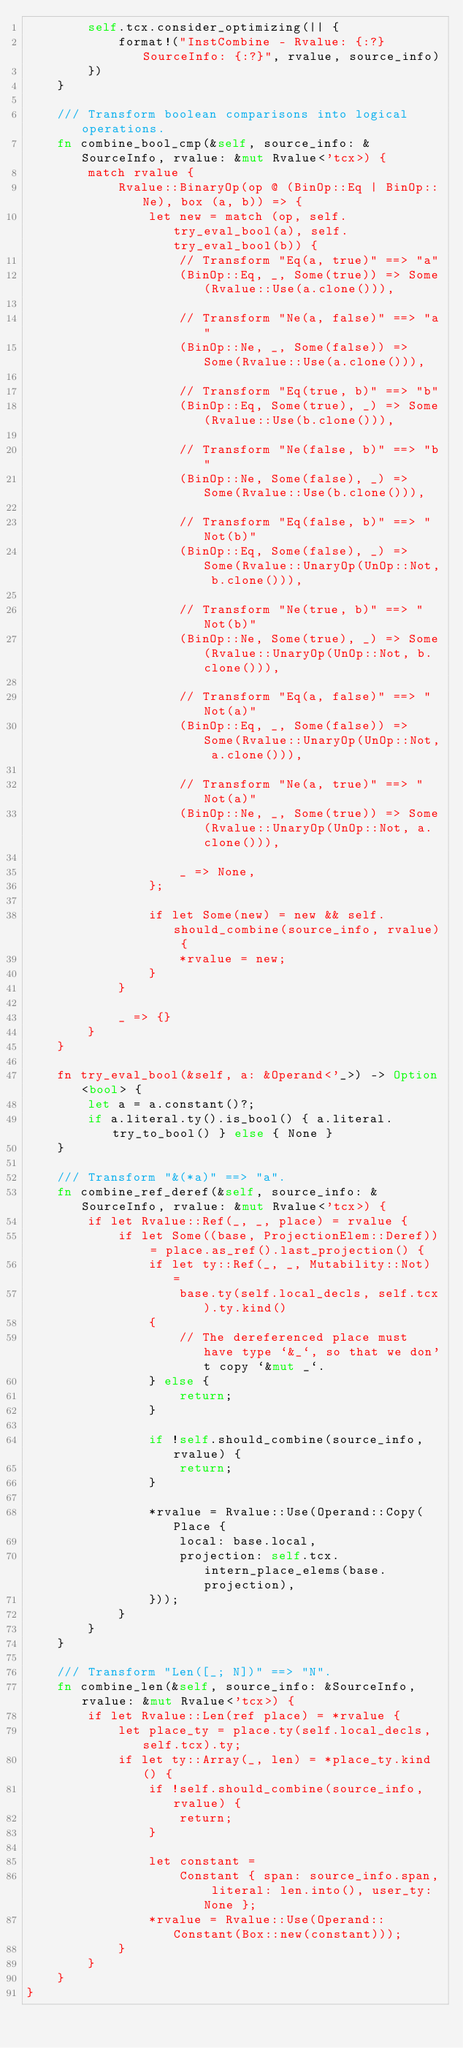Convert code to text. <code><loc_0><loc_0><loc_500><loc_500><_Rust_>        self.tcx.consider_optimizing(|| {
            format!("InstCombine - Rvalue: {:?} SourceInfo: {:?}", rvalue, source_info)
        })
    }

    /// Transform boolean comparisons into logical operations.
    fn combine_bool_cmp(&self, source_info: &SourceInfo, rvalue: &mut Rvalue<'tcx>) {
        match rvalue {
            Rvalue::BinaryOp(op @ (BinOp::Eq | BinOp::Ne), box (a, b)) => {
                let new = match (op, self.try_eval_bool(a), self.try_eval_bool(b)) {
                    // Transform "Eq(a, true)" ==> "a"
                    (BinOp::Eq, _, Some(true)) => Some(Rvalue::Use(a.clone())),

                    // Transform "Ne(a, false)" ==> "a"
                    (BinOp::Ne, _, Some(false)) => Some(Rvalue::Use(a.clone())),

                    // Transform "Eq(true, b)" ==> "b"
                    (BinOp::Eq, Some(true), _) => Some(Rvalue::Use(b.clone())),

                    // Transform "Ne(false, b)" ==> "b"
                    (BinOp::Ne, Some(false), _) => Some(Rvalue::Use(b.clone())),

                    // Transform "Eq(false, b)" ==> "Not(b)"
                    (BinOp::Eq, Some(false), _) => Some(Rvalue::UnaryOp(UnOp::Not, b.clone())),

                    // Transform "Ne(true, b)" ==> "Not(b)"
                    (BinOp::Ne, Some(true), _) => Some(Rvalue::UnaryOp(UnOp::Not, b.clone())),

                    // Transform "Eq(a, false)" ==> "Not(a)"
                    (BinOp::Eq, _, Some(false)) => Some(Rvalue::UnaryOp(UnOp::Not, a.clone())),

                    // Transform "Ne(a, true)" ==> "Not(a)"
                    (BinOp::Ne, _, Some(true)) => Some(Rvalue::UnaryOp(UnOp::Not, a.clone())),

                    _ => None,
                };

                if let Some(new) = new && self.should_combine(source_info, rvalue) {
                    *rvalue = new;
                }
            }

            _ => {}
        }
    }

    fn try_eval_bool(&self, a: &Operand<'_>) -> Option<bool> {
        let a = a.constant()?;
        if a.literal.ty().is_bool() { a.literal.try_to_bool() } else { None }
    }

    /// Transform "&(*a)" ==> "a".
    fn combine_ref_deref(&self, source_info: &SourceInfo, rvalue: &mut Rvalue<'tcx>) {
        if let Rvalue::Ref(_, _, place) = rvalue {
            if let Some((base, ProjectionElem::Deref)) = place.as_ref().last_projection() {
                if let ty::Ref(_, _, Mutability::Not) =
                    base.ty(self.local_decls, self.tcx).ty.kind()
                {
                    // The dereferenced place must have type `&_`, so that we don't copy `&mut _`.
                } else {
                    return;
                }

                if !self.should_combine(source_info, rvalue) {
                    return;
                }

                *rvalue = Rvalue::Use(Operand::Copy(Place {
                    local: base.local,
                    projection: self.tcx.intern_place_elems(base.projection),
                }));
            }
        }
    }

    /// Transform "Len([_; N])" ==> "N".
    fn combine_len(&self, source_info: &SourceInfo, rvalue: &mut Rvalue<'tcx>) {
        if let Rvalue::Len(ref place) = *rvalue {
            let place_ty = place.ty(self.local_decls, self.tcx).ty;
            if let ty::Array(_, len) = *place_ty.kind() {
                if !self.should_combine(source_info, rvalue) {
                    return;
                }

                let constant =
                    Constant { span: source_info.span, literal: len.into(), user_ty: None };
                *rvalue = Rvalue::Use(Operand::Constant(Box::new(constant)));
            }
        }
    }
}
</code> 